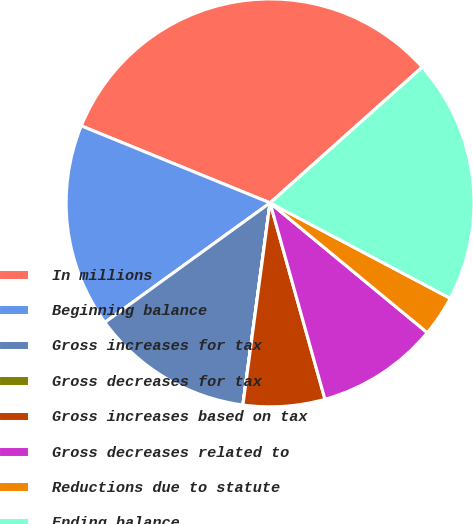<chart> <loc_0><loc_0><loc_500><loc_500><pie_chart><fcel>In millions<fcel>Beginning balance<fcel>Gross increases for tax<fcel>Gross decreases for tax<fcel>Gross increases based on tax<fcel>Gross decreases related to<fcel>Reductions due to statute<fcel>Ending balance<nl><fcel>32.24%<fcel>16.13%<fcel>12.9%<fcel>0.01%<fcel>6.46%<fcel>9.68%<fcel>3.23%<fcel>19.35%<nl></chart> 